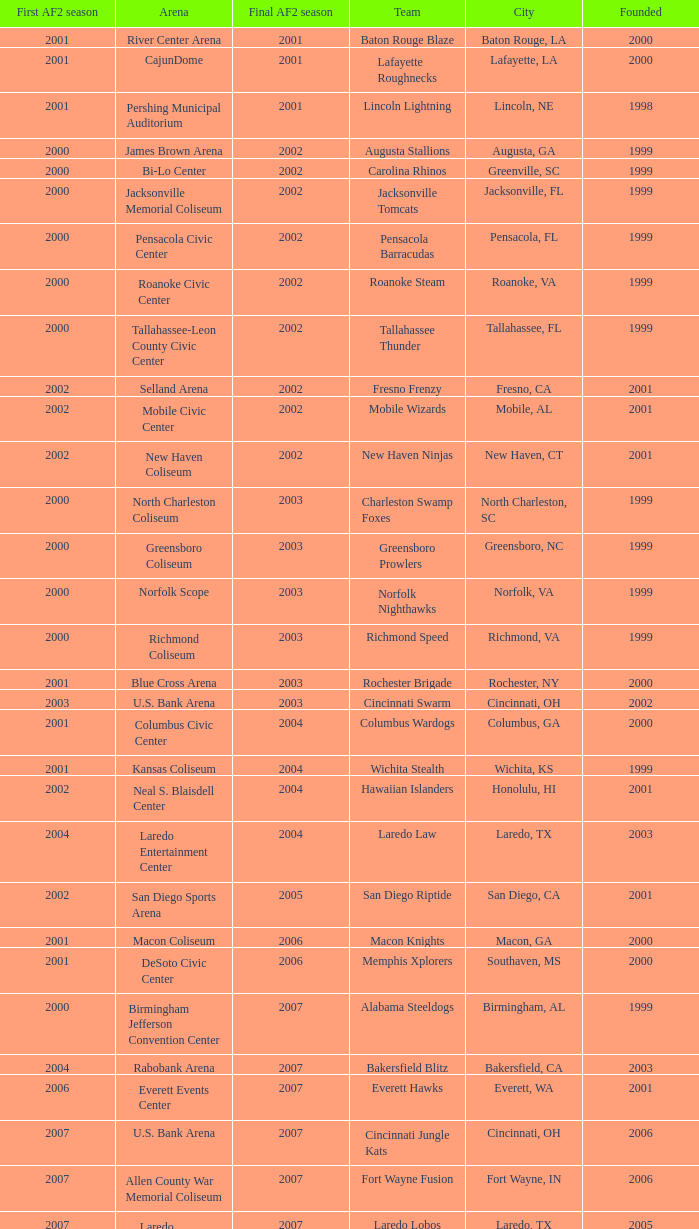How many founded years had a final af2 season prior to 2009 where the arena was the bi-lo center and the first af2 season was prior to 2000? 0.0. 